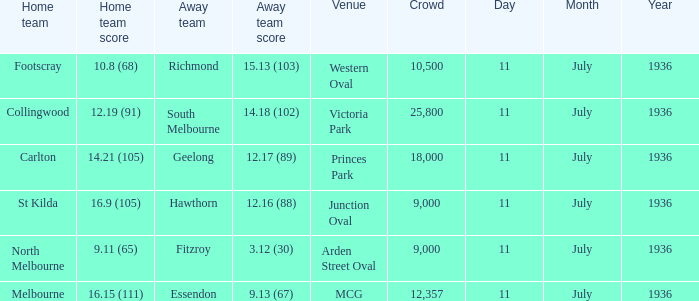When was the game with richmond as Away team? 11 July 1936. 